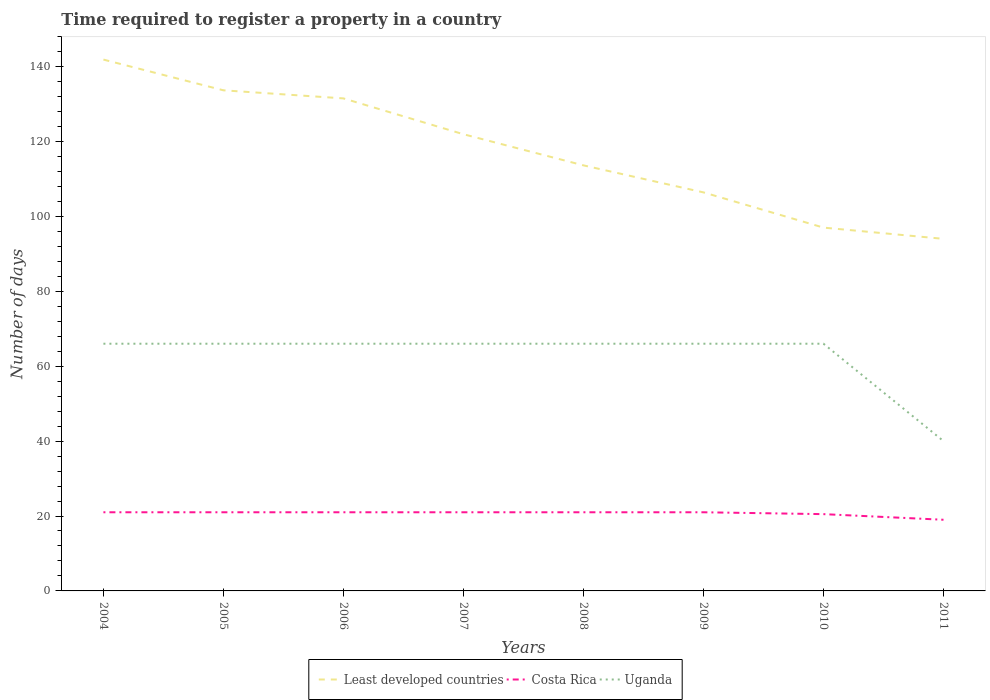How many different coloured lines are there?
Make the answer very short. 3. Does the line corresponding to Least developed countries intersect with the line corresponding to Costa Rica?
Offer a very short reply. No. Is the number of lines equal to the number of legend labels?
Give a very brief answer. Yes. Across all years, what is the maximum number of days required to register a property in Least developed countries?
Offer a terse response. 94. What is the total number of days required to register a property in Costa Rica in the graph?
Offer a very short reply. 2. What is the difference between the highest and the second highest number of days required to register a property in Least developed countries?
Give a very brief answer. 47.86. Is the number of days required to register a property in Least developed countries strictly greater than the number of days required to register a property in Uganda over the years?
Provide a succinct answer. No. How many lines are there?
Your answer should be compact. 3. How many years are there in the graph?
Your answer should be compact. 8. Are the values on the major ticks of Y-axis written in scientific E-notation?
Provide a short and direct response. No. Does the graph contain grids?
Offer a terse response. No. Where does the legend appear in the graph?
Ensure brevity in your answer.  Bottom center. What is the title of the graph?
Your answer should be compact. Time required to register a property in a country. What is the label or title of the X-axis?
Your answer should be compact. Years. What is the label or title of the Y-axis?
Ensure brevity in your answer.  Number of days. What is the Number of days of Least developed countries in 2004?
Provide a succinct answer. 141.86. What is the Number of days in Least developed countries in 2005?
Make the answer very short. 133.66. What is the Number of days in Costa Rica in 2005?
Provide a succinct answer. 21. What is the Number of days of Least developed countries in 2006?
Offer a very short reply. 131.5. What is the Number of days in Costa Rica in 2006?
Provide a succinct answer. 21. What is the Number of days of Least developed countries in 2007?
Your answer should be very brief. 121.93. What is the Number of days of Least developed countries in 2008?
Ensure brevity in your answer.  113.62. What is the Number of days of Costa Rica in 2008?
Make the answer very short. 21. What is the Number of days in Uganda in 2008?
Your answer should be very brief. 66. What is the Number of days of Least developed countries in 2009?
Offer a very short reply. 106.4. What is the Number of days in Costa Rica in 2009?
Offer a very short reply. 21. What is the Number of days in Least developed countries in 2010?
Your response must be concise. 97. What is the Number of days in Costa Rica in 2010?
Offer a very short reply. 20.5. What is the Number of days in Least developed countries in 2011?
Offer a very short reply. 94. What is the Number of days of Costa Rica in 2011?
Provide a succinct answer. 19. What is the Number of days of Uganda in 2011?
Ensure brevity in your answer.  40. Across all years, what is the maximum Number of days of Least developed countries?
Your answer should be compact. 141.86. Across all years, what is the minimum Number of days in Least developed countries?
Ensure brevity in your answer.  94. Across all years, what is the minimum Number of days of Costa Rica?
Your answer should be compact. 19. What is the total Number of days in Least developed countries in the graph?
Offer a terse response. 939.97. What is the total Number of days of Costa Rica in the graph?
Your answer should be compact. 165.5. What is the total Number of days of Uganda in the graph?
Your answer should be compact. 502. What is the difference between the Number of days of Least developed countries in 2004 and that in 2005?
Make the answer very short. 8.2. What is the difference between the Number of days in Costa Rica in 2004 and that in 2005?
Offer a terse response. 0. What is the difference between the Number of days in Least developed countries in 2004 and that in 2006?
Your response must be concise. 10.36. What is the difference between the Number of days of Costa Rica in 2004 and that in 2006?
Make the answer very short. 0. What is the difference between the Number of days in Uganda in 2004 and that in 2006?
Your response must be concise. 0. What is the difference between the Number of days of Least developed countries in 2004 and that in 2007?
Offer a terse response. 19.93. What is the difference between the Number of days of Costa Rica in 2004 and that in 2007?
Give a very brief answer. 0. What is the difference between the Number of days in Uganda in 2004 and that in 2007?
Provide a succinct answer. 0. What is the difference between the Number of days of Least developed countries in 2004 and that in 2008?
Offer a terse response. 28.24. What is the difference between the Number of days of Costa Rica in 2004 and that in 2008?
Provide a succinct answer. 0. What is the difference between the Number of days in Least developed countries in 2004 and that in 2009?
Offer a very short reply. 35.46. What is the difference between the Number of days of Costa Rica in 2004 and that in 2009?
Offer a very short reply. 0. What is the difference between the Number of days in Least developed countries in 2004 and that in 2010?
Provide a short and direct response. 44.86. What is the difference between the Number of days in Uganda in 2004 and that in 2010?
Provide a succinct answer. 0. What is the difference between the Number of days of Least developed countries in 2004 and that in 2011?
Make the answer very short. 47.86. What is the difference between the Number of days in Costa Rica in 2004 and that in 2011?
Your response must be concise. 2. What is the difference between the Number of days of Uganda in 2004 and that in 2011?
Ensure brevity in your answer.  26. What is the difference between the Number of days of Least developed countries in 2005 and that in 2006?
Provide a short and direct response. 2.16. What is the difference between the Number of days in Costa Rica in 2005 and that in 2006?
Offer a terse response. 0. What is the difference between the Number of days in Least developed countries in 2005 and that in 2007?
Provide a short and direct response. 11.73. What is the difference between the Number of days of Least developed countries in 2005 and that in 2008?
Offer a very short reply. 20.04. What is the difference between the Number of days in Uganda in 2005 and that in 2008?
Your response must be concise. 0. What is the difference between the Number of days in Least developed countries in 2005 and that in 2009?
Keep it short and to the point. 27.25. What is the difference between the Number of days of Costa Rica in 2005 and that in 2009?
Your answer should be very brief. 0. What is the difference between the Number of days in Uganda in 2005 and that in 2009?
Offer a very short reply. 0. What is the difference between the Number of days of Least developed countries in 2005 and that in 2010?
Provide a short and direct response. 36.66. What is the difference between the Number of days of Costa Rica in 2005 and that in 2010?
Offer a terse response. 0.5. What is the difference between the Number of days in Least developed countries in 2005 and that in 2011?
Provide a succinct answer. 39.66. What is the difference between the Number of days in Least developed countries in 2006 and that in 2007?
Provide a short and direct response. 9.57. What is the difference between the Number of days in Costa Rica in 2006 and that in 2007?
Your answer should be compact. 0. What is the difference between the Number of days in Uganda in 2006 and that in 2007?
Offer a very short reply. 0. What is the difference between the Number of days of Least developed countries in 2006 and that in 2008?
Keep it short and to the point. 17.88. What is the difference between the Number of days of Costa Rica in 2006 and that in 2008?
Make the answer very short. 0. What is the difference between the Number of days of Least developed countries in 2006 and that in 2009?
Ensure brevity in your answer.  25.1. What is the difference between the Number of days of Costa Rica in 2006 and that in 2009?
Ensure brevity in your answer.  0. What is the difference between the Number of days of Least developed countries in 2006 and that in 2010?
Offer a terse response. 34.5. What is the difference between the Number of days in Costa Rica in 2006 and that in 2010?
Provide a short and direct response. 0.5. What is the difference between the Number of days of Least developed countries in 2006 and that in 2011?
Your response must be concise. 37.5. What is the difference between the Number of days of Least developed countries in 2007 and that in 2008?
Your answer should be compact. 8.31. What is the difference between the Number of days of Least developed countries in 2007 and that in 2009?
Your answer should be compact. 15.52. What is the difference between the Number of days of Uganda in 2007 and that in 2009?
Ensure brevity in your answer.  0. What is the difference between the Number of days of Least developed countries in 2007 and that in 2010?
Offer a very short reply. 24.93. What is the difference between the Number of days of Costa Rica in 2007 and that in 2010?
Your answer should be very brief. 0.5. What is the difference between the Number of days of Uganda in 2007 and that in 2010?
Give a very brief answer. 0. What is the difference between the Number of days in Least developed countries in 2007 and that in 2011?
Keep it short and to the point. 27.93. What is the difference between the Number of days in Costa Rica in 2007 and that in 2011?
Your answer should be compact. 2. What is the difference between the Number of days in Least developed countries in 2008 and that in 2009?
Your answer should be compact. 7.21. What is the difference between the Number of days of Least developed countries in 2008 and that in 2010?
Keep it short and to the point. 16.62. What is the difference between the Number of days of Costa Rica in 2008 and that in 2010?
Provide a succinct answer. 0.5. What is the difference between the Number of days in Least developed countries in 2008 and that in 2011?
Your answer should be compact. 19.62. What is the difference between the Number of days in Least developed countries in 2009 and that in 2010?
Provide a succinct answer. 9.4. What is the difference between the Number of days in Costa Rica in 2009 and that in 2010?
Provide a short and direct response. 0.5. What is the difference between the Number of days of Uganda in 2009 and that in 2010?
Provide a short and direct response. 0. What is the difference between the Number of days of Least developed countries in 2009 and that in 2011?
Keep it short and to the point. 12.4. What is the difference between the Number of days of Costa Rica in 2009 and that in 2011?
Provide a short and direct response. 2. What is the difference between the Number of days in Least developed countries in 2010 and that in 2011?
Provide a short and direct response. 3. What is the difference between the Number of days in Costa Rica in 2010 and that in 2011?
Your response must be concise. 1.5. What is the difference between the Number of days in Least developed countries in 2004 and the Number of days in Costa Rica in 2005?
Offer a very short reply. 120.86. What is the difference between the Number of days of Least developed countries in 2004 and the Number of days of Uganda in 2005?
Your answer should be very brief. 75.86. What is the difference between the Number of days in Costa Rica in 2004 and the Number of days in Uganda in 2005?
Give a very brief answer. -45. What is the difference between the Number of days in Least developed countries in 2004 and the Number of days in Costa Rica in 2006?
Provide a succinct answer. 120.86. What is the difference between the Number of days in Least developed countries in 2004 and the Number of days in Uganda in 2006?
Your response must be concise. 75.86. What is the difference between the Number of days of Costa Rica in 2004 and the Number of days of Uganda in 2006?
Offer a terse response. -45. What is the difference between the Number of days of Least developed countries in 2004 and the Number of days of Costa Rica in 2007?
Offer a terse response. 120.86. What is the difference between the Number of days in Least developed countries in 2004 and the Number of days in Uganda in 2007?
Your response must be concise. 75.86. What is the difference between the Number of days of Costa Rica in 2004 and the Number of days of Uganda in 2007?
Keep it short and to the point. -45. What is the difference between the Number of days of Least developed countries in 2004 and the Number of days of Costa Rica in 2008?
Your response must be concise. 120.86. What is the difference between the Number of days of Least developed countries in 2004 and the Number of days of Uganda in 2008?
Keep it short and to the point. 75.86. What is the difference between the Number of days in Costa Rica in 2004 and the Number of days in Uganda in 2008?
Your answer should be compact. -45. What is the difference between the Number of days of Least developed countries in 2004 and the Number of days of Costa Rica in 2009?
Keep it short and to the point. 120.86. What is the difference between the Number of days of Least developed countries in 2004 and the Number of days of Uganda in 2009?
Make the answer very short. 75.86. What is the difference between the Number of days in Costa Rica in 2004 and the Number of days in Uganda in 2009?
Provide a succinct answer. -45. What is the difference between the Number of days of Least developed countries in 2004 and the Number of days of Costa Rica in 2010?
Provide a short and direct response. 121.36. What is the difference between the Number of days of Least developed countries in 2004 and the Number of days of Uganda in 2010?
Offer a very short reply. 75.86. What is the difference between the Number of days of Costa Rica in 2004 and the Number of days of Uganda in 2010?
Give a very brief answer. -45. What is the difference between the Number of days in Least developed countries in 2004 and the Number of days in Costa Rica in 2011?
Provide a succinct answer. 122.86. What is the difference between the Number of days of Least developed countries in 2004 and the Number of days of Uganda in 2011?
Offer a very short reply. 101.86. What is the difference between the Number of days of Costa Rica in 2004 and the Number of days of Uganda in 2011?
Provide a short and direct response. -19. What is the difference between the Number of days of Least developed countries in 2005 and the Number of days of Costa Rica in 2006?
Your answer should be compact. 112.66. What is the difference between the Number of days in Least developed countries in 2005 and the Number of days in Uganda in 2006?
Make the answer very short. 67.66. What is the difference between the Number of days of Costa Rica in 2005 and the Number of days of Uganda in 2006?
Provide a succinct answer. -45. What is the difference between the Number of days in Least developed countries in 2005 and the Number of days in Costa Rica in 2007?
Your response must be concise. 112.66. What is the difference between the Number of days in Least developed countries in 2005 and the Number of days in Uganda in 2007?
Provide a short and direct response. 67.66. What is the difference between the Number of days in Costa Rica in 2005 and the Number of days in Uganda in 2007?
Your answer should be very brief. -45. What is the difference between the Number of days in Least developed countries in 2005 and the Number of days in Costa Rica in 2008?
Offer a terse response. 112.66. What is the difference between the Number of days of Least developed countries in 2005 and the Number of days of Uganda in 2008?
Ensure brevity in your answer.  67.66. What is the difference between the Number of days of Costa Rica in 2005 and the Number of days of Uganda in 2008?
Keep it short and to the point. -45. What is the difference between the Number of days of Least developed countries in 2005 and the Number of days of Costa Rica in 2009?
Your answer should be compact. 112.66. What is the difference between the Number of days of Least developed countries in 2005 and the Number of days of Uganda in 2009?
Your response must be concise. 67.66. What is the difference between the Number of days of Costa Rica in 2005 and the Number of days of Uganda in 2009?
Ensure brevity in your answer.  -45. What is the difference between the Number of days of Least developed countries in 2005 and the Number of days of Costa Rica in 2010?
Provide a short and direct response. 113.16. What is the difference between the Number of days of Least developed countries in 2005 and the Number of days of Uganda in 2010?
Provide a succinct answer. 67.66. What is the difference between the Number of days of Costa Rica in 2005 and the Number of days of Uganda in 2010?
Give a very brief answer. -45. What is the difference between the Number of days of Least developed countries in 2005 and the Number of days of Costa Rica in 2011?
Your answer should be compact. 114.66. What is the difference between the Number of days in Least developed countries in 2005 and the Number of days in Uganda in 2011?
Ensure brevity in your answer.  93.66. What is the difference between the Number of days in Costa Rica in 2005 and the Number of days in Uganda in 2011?
Make the answer very short. -19. What is the difference between the Number of days of Least developed countries in 2006 and the Number of days of Costa Rica in 2007?
Provide a short and direct response. 110.5. What is the difference between the Number of days of Least developed countries in 2006 and the Number of days of Uganda in 2007?
Your answer should be compact. 65.5. What is the difference between the Number of days in Costa Rica in 2006 and the Number of days in Uganda in 2007?
Make the answer very short. -45. What is the difference between the Number of days in Least developed countries in 2006 and the Number of days in Costa Rica in 2008?
Keep it short and to the point. 110.5. What is the difference between the Number of days in Least developed countries in 2006 and the Number of days in Uganda in 2008?
Ensure brevity in your answer.  65.5. What is the difference between the Number of days of Costa Rica in 2006 and the Number of days of Uganda in 2008?
Give a very brief answer. -45. What is the difference between the Number of days in Least developed countries in 2006 and the Number of days in Costa Rica in 2009?
Offer a very short reply. 110.5. What is the difference between the Number of days of Least developed countries in 2006 and the Number of days of Uganda in 2009?
Offer a very short reply. 65.5. What is the difference between the Number of days of Costa Rica in 2006 and the Number of days of Uganda in 2009?
Your response must be concise. -45. What is the difference between the Number of days in Least developed countries in 2006 and the Number of days in Costa Rica in 2010?
Keep it short and to the point. 111. What is the difference between the Number of days in Least developed countries in 2006 and the Number of days in Uganda in 2010?
Your answer should be compact. 65.5. What is the difference between the Number of days in Costa Rica in 2006 and the Number of days in Uganda in 2010?
Your response must be concise. -45. What is the difference between the Number of days of Least developed countries in 2006 and the Number of days of Costa Rica in 2011?
Your answer should be compact. 112.5. What is the difference between the Number of days of Least developed countries in 2006 and the Number of days of Uganda in 2011?
Provide a short and direct response. 91.5. What is the difference between the Number of days of Least developed countries in 2007 and the Number of days of Costa Rica in 2008?
Give a very brief answer. 100.93. What is the difference between the Number of days in Least developed countries in 2007 and the Number of days in Uganda in 2008?
Provide a short and direct response. 55.93. What is the difference between the Number of days of Costa Rica in 2007 and the Number of days of Uganda in 2008?
Offer a terse response. -45. What is the difference between the Number of days in Least developed countries in 2007 and the Number of days in Costa Rica in 2009?
Your response must be concise. 100.93. What is the difference between the Number of days of Least developed countries in 2007 and the Number of days of Uganda in 2009?
Provide a short and direct response. 55.93. What is the difference between the Number of days in Costa Rica in 2007 and the Number of days in Uganda in 2009?
Provide a succinct answer. -45. What is the difference between the Number of days in Least developed countries in 2007 and the Number of days in Costa Rica in 2010?
Your answer should be compact. 101.43. What is the difference between the Number of days of Least developed countries in 2007 and the Number of days of Uganda in 2010?
Make the answer very short. 55.93. What is the difference between the Number of days in Costa Rica in 2007 and the Number of days in Uganda in 2010?
Your answer should be compact. -45. What is the difference between the Number of days in Least developed countries in 2007 and the Number of days in Costa Rica in 2011?
Your answer should be very brief. 102.93. What is the difference between the Number of days in Least developed countries in 2007 and the Number of days in Uganda in 2011?
Offer a terse response. 81.93. What is the difference between the Number of days of Costa Rica in 2007 and the Number of days of Uganda in 2011?
Give a very brief answer. -19. What is the difference between the Number of days in Least developed countries in 2008 and the Number of days in Costa Rica in 2009?
Your answer should be very brief. 92.62. What is the difference between the Number of days in Least developed countries in 2008 and the Number of days in Uganda in 2009?
Your response must be concise. 47.62. What is the difference between the Number of days in Costa Rica in 2008 and the Number of days in Uganda in 2009?
Make the answer very short. -45. What is the difference between the Number of days of Least developed countries in 2008 and the Number of days of Costa Rica in 2010?
Keep it short and to the point. 93.12. What is the difference between the Number of days of Least developed countries in 2008 and the Number of days of Uganda in 2010?
Offer a terse response. 47.62. What is the difference between the Number of days of Costa Rica in 2008 and the Number of days of Uganda in 2010?
Make the answer very short. -45. What is the difference between the Number of days of Least developed countries in 2008 and the Number of days of Costa Rica in 2011?
Offer a very short reply. 94.62. What is the difference between the Number of days of Least developed countries in 2008 and the Number of days of Uganda in 2011?
Offer a terse response. 73.62. What is the difference between the Number of days of Least developed countries in 2009 and the Number of days of Costa Rica in 2010?
Your response must be concise. 85.9. What is the difference between the Number of days in Least developed countries in 2009 and the Number of days in Uganda in 2010?
Your answer should be very brief. 40.4. What is the difference between the Number of days of Costa Rica in 2009 and the Number of days of Uganda in 2010?
Provide a succinct answer. -45. What is the difference between the Number of days of Least developed countries in 2009 and the Number of days of Costa Rica in 2011?
Your response must be concise. 87.4. What is the difference between the Number of days in Least developed countries in 2009 and the Number of days in Uganda in 2011?
Make the answer very short. 66.4. What is the difference between the Number of days in Costa Rica in 2009 and the Number of days in Uganda in 2011?
Offer a very short reply. -19. What is the difference between the Number of days of Least developed countries in 2010 and the Number of days of Uganda in 2011?
Offer a very short reply. 57. What is the difference between the Number of days of Costa Rica in 2010 and the Number of days of Uganda in 2011?
Offer a terse response. -19.5. What is the average Number of days in Least developed countries per year?
Your response must be concise. 117.5. What is the average Number of days in Costa Rica per year?
Keep it short and to the point. 20.69. What is the average Number of days in Uganda per year?
Offer a very short reply. 62.75. In the year 2004, what is the difference between the Number of days of Least developed countries and Number of days of Costa Rica?
Your answer should be very brief. 120.86. In the year 2004, what is the difference between the Number of days in Least developed countries and Number of days in Uganda?
Provide a succinct answer. 75.86. In the year 2004, what is the difference between the Number of days in Costa Rica and Number of days in Uganda?
Provide a succinct answer. -45. In the year 2005, what is the difference between the Number of days in Least developed countries and Number of days in Costa Rica?
Keep it short and to the point. 112.66. In the year 2005, what is the difference between the Number of days of Least developed countries and Number of days of Uganda?
Provide a short and direct response. 67.66. In the year 2005, what is the difference between the Number of days of Costa Rica and Number of days of Uganda?
Provide a short and direct response. -45. In the year 2006, what is the difference between the Number of days in Least developed countries and Number of days in Costa Rica?
Your answer should be very brief. 110.5. In the year 2006, what is the difference between the Number of days in Least developed countries and Number of days in Uganda?
Offer a very short reply. 65.5. In the year 2006, what is the difference between the Number of days of Costa Rica and Number of days of Uganda?
Offer a very short reply. -45. In the year 2007, what is the difference between the Number of days in Least developed countries and Number of days in Costa Rica?
Your response must be concise. 100.93. In the year 2007, what is the difference between the Number of days in Least developed countries and Number of days in Uganda?
Your answer should be compact. 55.93. In the year 2007, what is the difference between the Number of days of Costa Rica and Number of days of Uganda?
Give a very brief answer. -45. In the year 2008, what is the difference between the Number of days in Least developed countries and Number of days in Costa Rica?
Provide a succinct answer. 92.62. In the year 2008, what is the difference between the Number of days in Least developed countries and Number of days in Uganda?
Make the answer very short. 47.62. In the year 2008, what is the difference between the Number of days in Costa Rica and Number of days in Uganda?
Keep it short and to the point. -45. In the year 2009, what is the difference between the Number of days of Least developed countries and Number of days of Costa Rica?
Your answer should be compact. 85.4. In the year 2009, what is the difference between the Number of days of Least developed countries and Number of days of Uganda?
Provide a succinct answer. 40.4. In the year 2009, what is the difference between the Number of days of Costa Rica and Number of days of Uganda?
Ensure brevity in your answer.  -45. In the year 2010, what is the difference between the Number of days in Least developed countries and Number of days in Costa Rica?
Keep it short and to the point. 76.5. In the year 2010, what is the difference between the Number of days in Costa Rica and Number of days in Uganda?
Provide a short and direct response. -45.5. In the year 2011, what is the difference between the Number of days in Least developed countries and Number of days in Uganda?
Provide a succinct answer. 54. What is the ratio of the Number of days of Least developed countries in 2004 to that in 2005?
Offer a terse response. 1.06. What is the ratio of the Number of days in Least developed countries in 2004 to that in 2006?
Offer a terse response. 1.08. What is the ratio of the Number of days of Costa Rica in 2004 to that in 2006?
Keep it short and to the point. 1. What is the ratio of the Number of days of Uganda in 2004 to that in 2006?
Ensure brevity in your answer.  1. What is the ratio of the Number of days of Least developed countries in 2004 to that in 2007?
Offer a terse response. 1.16. What is the ratio of the Number of days in Costa Rica in 2004 to that in 2007?
Provide a succinct answer. 1. What is the ratio of the Number of days of Uganda in 2004 to that in 2007?
Give a very brief answer. 1. What is the ratio of the Number of days of Least developed countries in 2004 to that in 2008?
Ensure brevity in your answer.  1.25. What is the ratio of the Number of days of Costa Rica in 2004 to that in 2008?
Provide a succinct answer. 1. What is the ratio of the Number of days of Uganda in 2004 to that in 2008?
Offer a terse response. 1. What is the ratio of the Number of days in Least developed countries in 2004 to that in 2009?
Make the answer very short. 1.33. What is the ratio of the Number of days in Least developed countries in 2004 to that in 2010?
Offer a terse response. 1.46. What is the ratio of the Number of days in Costa Rica in 2004 to that in 2010?
Keep it short and to the point. 1.02. What is the ratio of the Number of days in Least developed countries in 2004 to that in 2011?
Provide a succinct answer. 1.51. What is the ratio of the Number of days in Costa Rica in 2004 to that in 2011?
Ensure brevity in your answer.  1.11. What is the ratio of the Number of days of Uganda in 2004 to that in 2011?
Ensure brevity in your answer.  1.65. What is the ratio of the Number of days of Least developed countries in 2005 to that in 2006?
Your response must be concise. 1.02. What is the ratio of the Number of days of Uganda in 2005 to that in 2006?
Provide a succinct answer. 1. What is the ratio of the Number of days in Least developed countries in 2005 to that in 2007?
Your answer should be compact. 1.1. What is the ratio of the Number of days in Least developed countries in 2005 to that in 2008?
Your response must be concise. 1.18. What is the ratio of the Number of days in Costa Rica in 2005 to that in 2008?
Your answer should be compact. 1. What is the ratio of the Number of days in Uganda in 2005 to that in 2008?
Your answer should be very brief. 1. What is the ratio of the Number of days in Least developed countries in 2005 to that in 2009?
Your answer should be very brief. 1.26. What is the ratio of the Number of days of Costa Rica in 2005 to that in 2009?
Your response must be concise. 1. What is the ratio of the Number of days of Least developed countries in 2005 to that in 2010?
Make the answer very short. 1.38. What is the ratio of the Number of days of Costa Rica in 2005 to that in 2010?
Ensure brevity in your answer.  1.02. What is the ratio of the Number of days of Least developed countries in 2005 to that in 2011?
Your response must be concise. 1.42. What is the ratio of the Number of days of Costa Rica in 2005 to that in 2011?
Ensure brevity in your answer.  1.11. What is the ratio of the Number of days of Uganda in 2005 to that in 2011?
Your response must be concise. 1.65. What is the ratio of the Number of days of Least developed countries in 2006 to that in 2007?
Make the answer very short. 1.08. What is the ratio of the Number of days of Uganda in 2006 to that in 2007?
Offer a terse response. 1. What is the ratio of the Number of days in Least developed countries in 2006 to that in 2008?
Give a very brief answer. 1.16. What is the ratio of the Number of days in Least developed countries in 2006 to that in 2009?
Offer a terse response. 1.24. What is the ratio of the Number of days of Uganda in 2006 to that in 2009?
Offer a very short reply. 1. What is the ratio of the Number of days of Least developed countries in 2006 to that in 2010?
Make the answer very short. 1.36. What is the ratio of the Number of days in Costa Rica in 2006 to that in 2010?
Your response must be concise. 1.02. What is the ratio of the Number of days of Least developed countries in 2006 to that in 2011?
Your response must be concise. 1.4. What is the ratio of the Number of days of Costa Rica in 2006 to that in 2011?
Offer a very short reply. 1.11. What is the ratio of the Number of days of Uganda in 2006 to that in 2011?
Your response must be concise. 1.65. What is the ratio of the Number of days in Least developed countries in 2007 to that in 2008?
Your answer should be very brief. 1.07. What is the ratio of the Number of days in Least developed countries in 2007 to that in 2009?
Your answer should be very brief. 1.15. What is the ratio of the Number of days in Least developed countries in 2007 to that in 2010?
Offer a terse response. 1.26. What is the ratio of the Number of days of Costa Rica in 2007 to that in 2010?
Ensure brevity in your answer.  1.02. What is the ratio of the Number of days of Uganda in 2007 to that in 2010?
Offer a very short reply. 1. What is the ratio of the Number of days in Least developed countries in 2007 to that in 2011?
Provide a succinct answer. 1.3. What is the ratio of the Number of days of Costa Rica in 2007 to that in 2011?
Your answer should be very brief. 1.11. What is the ratio of the Number of days in Uganda in 2007 to that in 2011?
Ensure brevity in your answer.  1.65. What is the ratio of the Number of days of Least developed countries in 2008 to that in 2009?
Keep it short and to the point. 1.07. What is the ratio of the Number of days in Uganda in 2008 to that in 2009?
Provide a succinct answer. 1. What is the ratio of the Number of days in Least developed countries in 2008 to that in 2010?
Make the answer very short. 1.17. What is the ratio of the Number of days in Costa Rica in 2008 to that in 2010?
Your answer should be very brief. 1.02. What is the ratio of the Number of days in Least developed countries in 2008 to that in 2011?
Offer a terse response. 1.21. What is the ratio of the Number of days of Costa Rica in 2008 to that in 2011?
Offer a very short reply. 1.11. What is the ratio of the Number of days of Uganda in 2008 to that in 2011?
Keep it short and to the point. 1.65. What is the ratio of the Number of days of Least developed countries in 2009 to that in 2010?
Ensure brevity in your answer.  1.1. What is the ratio of the Number of days in Costa Rica in 2009 to that in 2010?
Your answer should be very brief. 1.02. What is the ratio of the Number of days in Least developed countries in 2009 to that in 2011?
Offer a very short reply. 1.13. What is the ratio of the Number of days in Costa Rica in 2009 to that in 2011?
Give a very brief answer. 1.11. What is the ratio of the Number of days of Uganda in 2009 to that in 2011?
Ensure brevity in your answer.  1.65. What is the ratio of the Number of days of Least developed countries in 2010 to that in 2011?
Offer a terse response. 1.03. What is the ratio of the Number of days in Costa Rica in 2010 to that in 2011?
Provide a short and direct response. 1.08. What is the ratio of the Number of days in Uganda in 2010 to that in 2011?
Keep it short and to the point. 1.65. What is the difference between the highest and the second highest Number of days in Least developed countries?
Provide a short and direct response. 8.2. What is the difference between the highest and the second highest Number of days in Costa Rica?
Offer a very short reply. 0. What is the difference between the highest and the second highest Number of days in Uganda?
Your answer should be very brief. 0. What is the difference between the highest and the lowest Number of days in Least developed countries?
Give a very brief answer. 47.86. What is the difference between the highest and the lowest Number of days of Uganda?
Your answer should be compact. 26. 